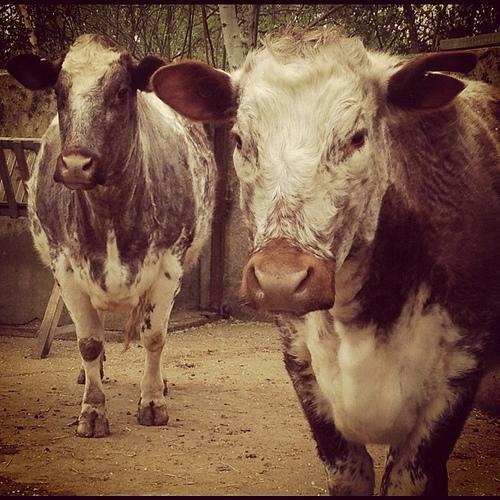How many cows are there?
Give a very brief answer. 2. How many ears does each cow have?
Give a very brief answer. 2. 